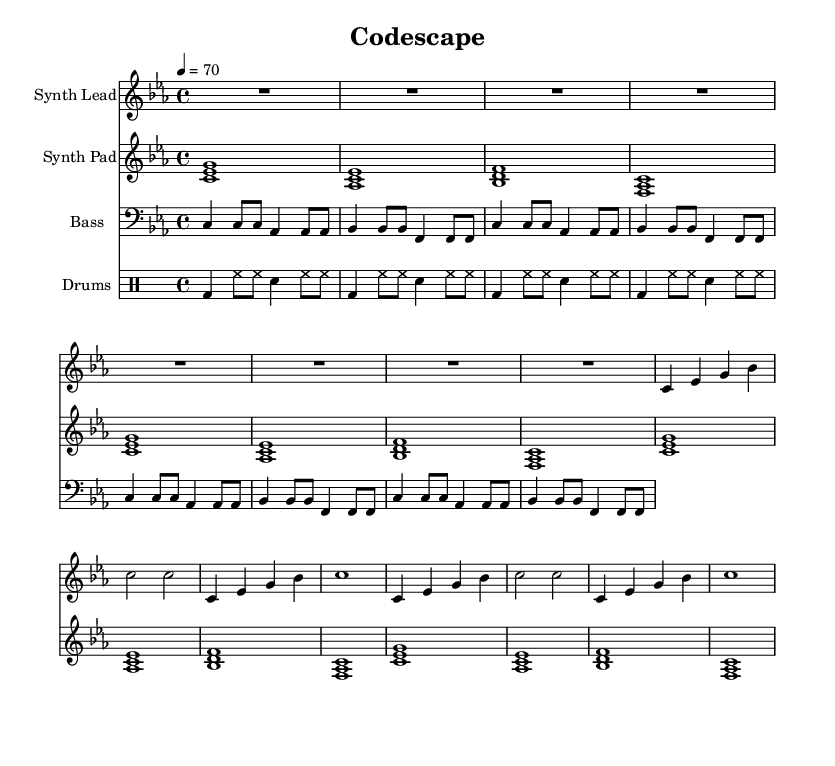What is the key signature of this music? The key signature is indicated by the presence of B flats and E flats. In the context of this music, the key signature is C minor, which has three flats: B flat, E flat, and A flat.
Answer: C minor What is the time signature of this piece? The time signature appears at the beginning of the sheet music, indicated as 4/4. This means there are four beats in each measure and the quarter note gets one beat.
Answer: 4/4 What is the tempo marking given for this music? The tempo is indicated by the marking "4 = 70," meaning that the quarter note is played at a speed of 70 beats per minute. This provides a moderate pace for the piece.
Answer: 70 How many measures are there in the synth lead? By counting the lines and the corresponding measures, we can determine that the synth lead has a total of 8 measures. Each line represents two measures, and there are four lines, which confirms this count.
Answer: 8 What instruments are featured in this composition? The sheet music specifies different instruments in separate staves: Synth Lead, Synth Pad, Bass, and Drums. Therefore, the composition features four instruments in total.
Answer: Synth Lead, Synth Pad, Bass, Drums What rhythmic pattern is established by the drums? The drum pattern consists of bass drum (bd), hi-hat (hh), and snare (sn) in a repeating sequence. Specifically, it has a rhythmic structure of a bass drum on beat one, a steady stream of hi-hats, and a snare hit on the third beat of each measure.
Answer: Bass, Hi-hat, Snare 